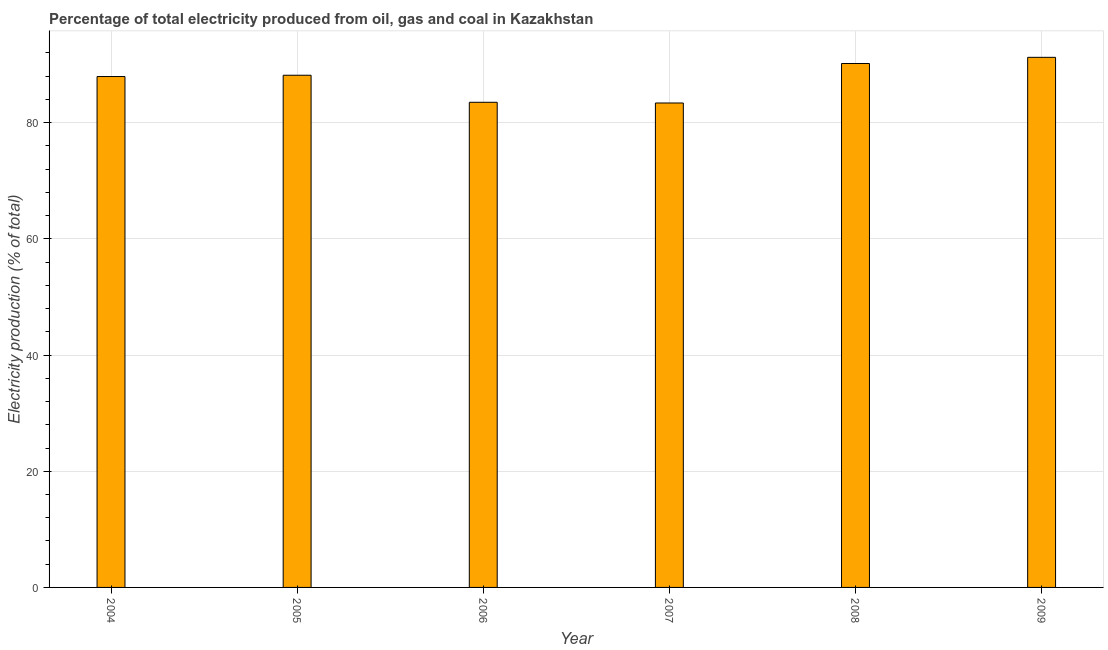Does the graph contain any zero values?
Offer a very short reply. No. Does the graph contain grids?
Offer a very short reply. Yes. What is the title of the graph?
Your response must be concise. Percentage of total electricity produced from oil, gas and coal in Kazakhstan. What is the label or title of the X-axis?
Your response must be concise. Year. What is the label or title of the Y-axis?
Your answer should be very brief. Electricity production (% of total). What is the electricity production in 2005?
Provide a short and direct response. 88.17. Across all years, what is the maximum electricity production?
Provide a succinct answer. 91.25. Across all years, what is the minimum electricity production?
Offer a very short reply. 83.39. In which year was the electricity production minimum?
Your answer should be very brief. 2007. What is the sum of the electricity production?
Offer a terse response. 524.46. What is the difference between the electricity production in 2007 and 2008?
Make the answer very short. -6.8. What is the average electricity production per year?
Give a very brief answer. 87.41. What is the median electricity production?
Offer a terse response. 88.06. In how many years, is the electricity production greater than 40 %?
Your answer should be compact. 6. What is the ratio of the electricity production in 2006 to that in 2009?
Keep it short and to the point. 0.92. Is the electricity production in 2007 less than that in 2008?
Your answer should be very brief. Yes. Is the difference between the electricity production in 2006 and 2008 greater than the difference between any two years?
Provide a succinct answer. No. What is the difference between the highest and the second highest electricity production?
Make the answer very short. 1.06. Is the sum of the electricity production in 2008 and 2009 greater than the maximum electricity production across all years?
Your response must be concise. Yes. What is the difference between the highest and the lowest electricity production?
Your answer should be compact. 7.86. In how many years, is the electricity production greater than the average electricity production taken over all years?
Provide a succinct answer. 4. How many bars are there?
Offer a terse response. 6. Are all the bars in the graph horizontal?
Your answer should be very brief. No. What is the difference between two consecutive major ticks on the Y-axis?
Keep it short and to the point. 20. Are the values on the major ticks of Y-axis written in scientific E-notation?
Ensure brevity in your answer.  No. What is the Electricity production (% of total) of 2004?
Provide a succinct answer. 87.94. What is the Electricity production (% of total) in 2005?
Your answer should be very brief. 88.17. What is the Electricity production (% of total) in 2006?
Offer a very short reply. 83.51. What is the Electricity production (% of total) in 2007?
Make the answer very short. 83.39. What is the Electricity production (% of total) in 2008?
Provide a succinct answer. 90.19. What is the Electricity production (% of total) in 2009?
Make the answer very short. 91.25. What is the difference between the Electricity production (% of total) in 2004 and 2005?
Offer a very short reply. -0.23. What is the difference between the Electricity production (% of total) in 2004 and 2006?
Offer a very short reply. 4.43. What is the difference between the Electricity production (% of total) in 2004 and 2007?
Keep it short and to the point. 4.55. What is the difference between the Electricity production (% of total) in 2004 and 2008?
Your response must be concise. -2.25. What is the difference between the Electricity production (% of total) in 2004 and 2009?
Provide a succinct answer. -3.31. What is the difference between the Electricity production (% of total) in 2005 and 2006?
Make the answer very short. 4.66. What is the difference between the Electricity production (% of total) in 2005 and 2007?
Offer a terse response. 4.78. What is the difference between the Electricity production (% of total) in 2005 and 2008?
Your response must be concise. -2.02. What is the difference between the Electricity production (% of total) in 2005 and 2009?
Make the answer very short. -3.08. What is the difference between the Electricity production (% of total) in 2006 and 2007?
Your response must be concise. 0.12. What is the difference between the Electricity production (% of total) in 2006 and 2008?
Your answer should be very brief. -6.68. What is the difference between the Electricity production (% of total) in 2006 and 2009?
Give a very brief answer. -7.74. What is the difference between the Electricity production (% of total) in 2007 and 2008?
Your response must be concise. -6.8. What is the difference between the Electricity production (% of total) in 2007 and 2009?
Provide a short and direct response. -7.86. What is the difference between the Electricity production (% of total) in 2008 and 2009?
Your answer should be compact. -1.06. What is the ratio of the Electricity production (% of total) in 2004 to that in 2005?
Offer a very short reply. 1. What is the ratio of the Electricity production (% of total) in 2004 to that in 2006?
Make the answer very short. 1.05. What is the ratio of the Electricity production (% of total) in 2004 to that in 2007?
Ensure brevity in your answer.  1.05. What is the ratio of the Electricity production (% of total) in 2004 to that in 2008?
Offer a terse response. 0.97. What is the ratio of the Electricity production (% of total) in 2005 to that in 2006?
Offer a terse response. 1.06. What is the ratio of the Electricity production (% of total) in 2005 to that in 2007?
Keep it short and to the point. 1.06. What is the ratio of the Electricity production (% of total) in 2005 to that in 2008?
Your response must be concise. 0.98. What is the ratio of the Electricity production (% of total) in 2006 to that in 2008?
Provide a short and direct response. 0.93. What is the ratio of the Electricity production (% of total) in 2006 to that in 2009?
Give a very brief answer. 0.92. What is the ratio of the Electricity production (% of total) in 2007 to that in 2008?
Ensure brevity in your answer.  0.93. What is the ratio of the Electricity production (% of total) in 2007 to that in 2009?
Your response must be concise. 0.91. 